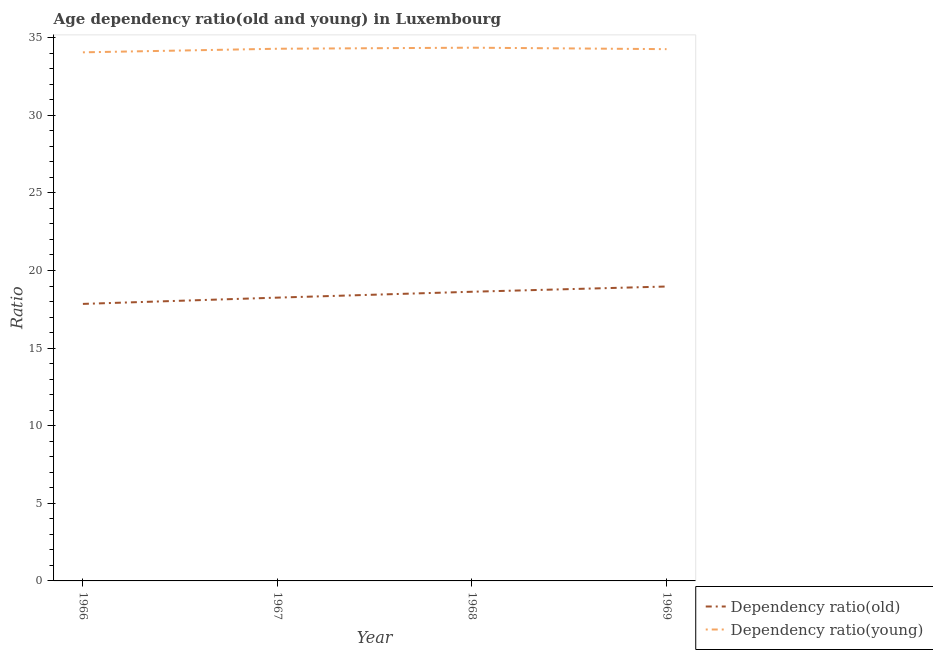How many different coloured lines are there?
Provide a succinct answer. 2. Does the line corresponding to age dependency ratio(young) intersect with the line corresponding to age dependency ratio(old)?
Keep it short and to the point. No. What is the age dependency ratio(young) in 1968?
Your answer should be compact. 34.35. Across all years, what is the maximum age dependency ratio(old)?
Ensure brevity in your answer.  18.97. Across all years, what is the minimum age dependency ratio(young)?
Your answer should be compact. 34.05. In which year was the age dependency ratio(old) maximum?
Your answer should be compact. 1969. In which year was the age dependency ratio(young) minimum?
Provide a succinct answer. 1966. What is the total age dependency ratio(old) in the graph?
Keep it short and to the point. 73.7. What is the difference between the age dependency ratio(young) in 1967 and that in 1968?
Provide a succinct answer. -0.07. What is the difference between the age dependency ratio(old) in 1969 and the age dependency ratio(young) in 1968?
Your answer should be compact. -15.39. What is the average age dependency ratio(young) per year?
Give a very brief answer. 34.24. In the year 1969, what is the difference between the age dependency ratio(young) and age dependency ratio(old)?
Provide a short and direct response. 15.29. In how many years, is the age dependency ratio(young) greater than 26?
Your answer should be very brief. 4. What is the ratio of the age dependency ratio(old) in 1967 to that in 1968?
Provide a succinct answer. 0.98. Is the age dependency ratio(old) in 1967 less than that in 1969?
Provide a succinct answer. Yes. What is the difference between the highest and the second highest age dependency ratio(young)?
Ensure brevity in your answer.  0.07. What is the difference between the highest and the lowest age dependency ratio(young)?
Provide a short and direct response. 0.3. In how many years, is the age dependency ratio(old) greater than the average age dependency ratio(old) taken over all years?
Give a very brief answer. 2. Does the age dependency ratio(old) monotonically increase over the years?
Your response must be concise. Yes. Is the age dependency ratio(old) strictly greater than the age dependency ratio(young) over the years?
Ensure brevity in your answer.  No. How many lines are there?
Your answer should be very brief. 2. Are the values on the major ticks of Y-axis written in scientific E-notation?
Offer a terse response. No. Does the graph contain any zero values?
Make the answer very short. No. Does the graph contain grids?
Make the answer very short. No. Where does the legend appear in the graph?
Your response must be concise. Bottom right. How many legend labels are there?
Keep it short and to the point. 2. What is the title of the graph?
Offer a very short reply. Age dependency ratio(old and young) in Luxembourg. Does "Primary income" appear as one of the legend labels in the graph?
Offer a terse response. No. What is the label or title of the X-axis?
Give a very brief answer. Year. What is the label or title of the Y-axis?
Ensure brevity in your answer.  Ratio. What is the Ratio of Dependency ratio(old) in 1966?
Ensure brevity in your answer.  17.85. What is the Ratio in Dependency ratio(young) in 1966?
Provide a short and direct response. 34.05. What is the Ratio of Dependency ratio(old) in 1967?
Offer a very short reply. 18.25. What is the Ratio of Dependency ratio(young) in 1967?
Your answer should be very brief. 34.29. What is the Ratio of Dependency ratio(old) in 1968?
Your answer should be very brief. 18.63. What is the Ratio of Dependency ratio(young) in 1968?
Make the answer very short. 34.35. What is the Ratio in Dependency ratio(old) in 1969?
Your answer should be compact. 18.97. What is the Ratio in Dependency ratio(young) in 1969?
Your response must be concise. 34.26. Across all years, what is the maximum Ratio in Dependency ratio(old)?
Keep it short and to the point. 18.97. Across all years, what is the maximum Ratio of Dependency ratio(young)?
Provide a short and direct response. 34.35. Across all years, what is the minimum Ratio of Dependency ratio(old)?
Ensure brevity in your answer.  17.85. Across all years, what is the minimum Ratio in Dependency ratio(young)?
Make the answer very short. 34.05. What is the total Ratio of Dependency ratio(old) in the graph?
Give a very brief answer. 73.7. What is the total Ratio in Dependency ratio(young) in the graph?
Offer a very short reply. 136.95. What is the difference between the Ratio in Dependency ratio(old) in 1966 and that in 1967?
Make the answer very short. -0.4. What is the difference between the Ratio in Dependency ratio(young) in 1966 and that in 1967?
Your answer should be compact. -0.23. What is the difference between the Ratio of Dependency ratio(old) in 1966 and that in 1968?
Your answer should be compact. -0.78. What is the difference between the Ratio in Dependency ratio(young) in 1966 and that in 1968?
Keep it short and to the point. -0.3. What is the difference between the Ratio in Dependency ratio(old) in 1966 and that in 1969?
Your answer should be compact. -1.12. What is the difference between the Ratio in Dependency ratio(young) in 1966 and that in 1969?
Your answer should be very brief. -0.21. What is the difference between the Ratio in Dependency ratio(old) in 1967 and that in 1968?
Ensure brevity in your answer.  -0.38. What is the difference between the Ratio of Dependency ratio(young) in 1967 and that in 1968?
Provide a succinct answer. -0.07. What is the difference between the Ratio of Dependency ratio(old) in 1967 and that in 1969?
Your answer should be compact. -0.72. What is the difference between the Ratio of Dependency ratio(young) in 1967 and that in 1969?
Provide a short and direct response. 0.03. What is the difference between the Ratio of Dependency ratio(old) in 1968 and that in 1969?
Make the answer very short. -0.34. What is the difference between the Ratio of Dependency ratio(young) in 1968 and that in 1969?
Offer a very short reply. 0.09. What is the difference between the Ratio of Dependency ratio(old) in 1966 and the Ratio of Dependency ratio(young) in 1967?
Ensure brevity in your answer.  -16.44. What is the difference between the Ratio of Dependency ratio(old) in 1966 and the Ratio of Dependency ratio(young) in 1968?
Keep it short and to the point. -16.51. What is the difference between the Ratio of Dependency ratio(old) in 1966 and the Ratio of Dependency ratio(young) in 1969?
Provide a short and direct response. -16.41. What is the difference between the Ratio in Dependency ratio(old) in 1967 and the Ratio in Dependency ratio(young) in 1968?
Provide a succinct answer. -16.1. What is the difference between the Ratio in Dependency ratio(old) in 1967 and the Ratio in Dependency ratio(young) in 1969?
Provide a short and direct response. -16.01. What is the difference between the Ratio in Dependency ratio(old) in 1968 and the Ratio in Dependency ratio(young) in 1969?
Provide a succinct answer. -15.63. What is the average Ratio of Dependency ratio(old) per year?
Make the answer very short. 18.42. What is the average Ratio in Dependency ratio(young) per year?
Make the answer very short. 34.24. In the year 1966, what is the difference between the Ratio in Dependency ratio(old) and Ratio in Dependency ratio(young)?
Keep it short and to the point. -16.21. In the year 1967, what is the difference between the Ratio in Dependency ratio(old) and Ratio in Dependency ratio(young)?
Offer a terse response. -16.03. In the year 1968, what is the difference between the Ratio of Dependency ratio(old) and Ratio of Dependency ratio(young)?
Your answer should be compact. -15.72. In the year 1969, what is the difference between the Ratio in Dependency ratio(old) and Ratio in Dependency ratio(young)?
Your response must be concise. -15.29. What is the ratio of the Ratio in Dependency ratio(old) in 1966 to that in 1967?
Your answer should be very brief. 0.98. What is the ratio of the Ratio of Dependency ratio(young) in 1966 to that in 1967?
Give a very brief answer. 0.99. What is the ratio of the Ratio of Dependency ratio(old) in 1966 to that in 1968?
Offer a terse response. 0.96. What is the ratio of the Ratio of Dependency ratio(old) in 1966 to that in 1969?
Give a very brief answer. 0.94. What is the ratio of the Ratio in Dependency ratio(young) in 1966 to that in 1969?
Offer a terse response. 0.99. What is the ratio of the Ratio in Dependency ratio(old) in 1967 to that in 1968?
Provide a succinct answer. 0.98. What is the ratio of the Ratio in Dependency ratio(old) in 1967 to that in 1969?
Keep it short and to the point. 0.96. What is the ratio of the Ratio in Dependency ratio(old) in 1968 to that in 1969?
Your response must be concise. 0.98. What is the difference between the highest and the second highest Ratio in Dependency ratio(old)?
Keep it short and to the point. 0.34. What is the difference between the highest and the second highest Ratio of Dependency ratio(young)?
Your answer should be compact. 0.07. What is the difference between the highest and the lowest Ratio of Dependency ratio(old)?
Ensure brevity in your answer.  1.12. What is the difference between the highest and the lowest Ratio in Dependency ratio(young)?
Your answer should be compact. 0.3. 